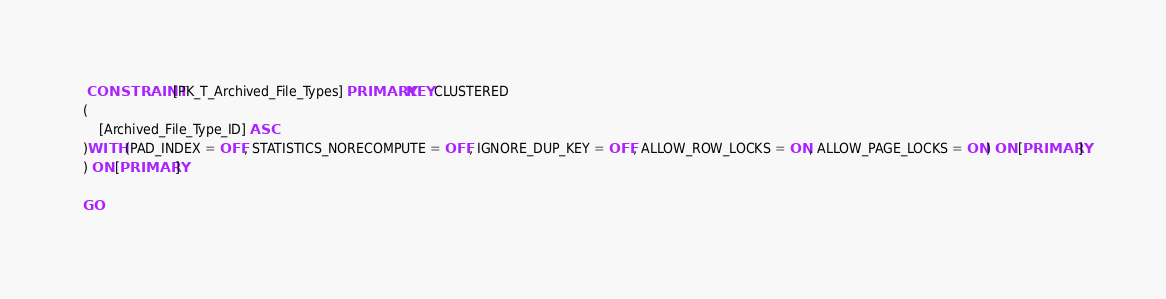Convert code to text. <code><loc_0><loc_0><loc_500><loc_500><_SQL_> CONSTRAINT [PK_T_Archived_File_Types] PRIMARY KEY CLUSTERED 
(
	[Archived_File_Type_ID] ASC
)WITH (PAD_INDEX = OFF, STATISTICS_NORECOMPUTE = OFF, IGNORE_DUP_KEY = OFF, ALLOW_ROW_LOCKS = ON, ALLOW_PAGE_LOCKS = ON) ON [PRIMARY]
) ON [PRIMARY]

GO
</code> 